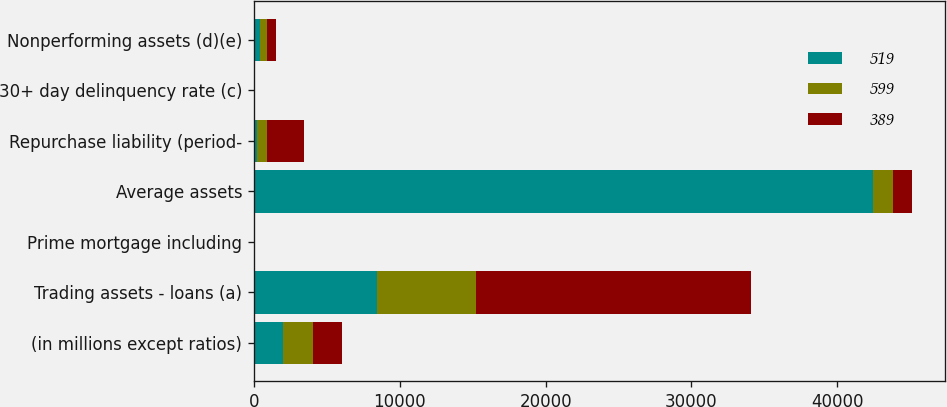Convert chart. <chart><loc_0><loc_0><loc_500><loc_500><stacked_bar_chart><ecel><fcel>(in millions except ratios)<fcel>Trading assets - loans (a)<fcel>Prime mortgage including<fcel>Average assets<fcel>Repurchase liability (period-<fcel>30+ day delinquency rate (c)<fcel>Nonperforming assets (d)(e)<nl><fcel>519<fcel>2014<fcel>8423<fcel>6<fcel>42456<fcel>249<fcel>2.06<fcel>389<nl><fcel>599<fcel>2013<fcel>6832<fcel>12<fcel>1331.5<fcel>651<fcel>2.75<fcel>519<nl><fcel>389<fcel>2012<fcel>18801<fcel>19<fcel>1331.5<fcel>2530<fcel>3.05<fcel>599<nl></chart> 